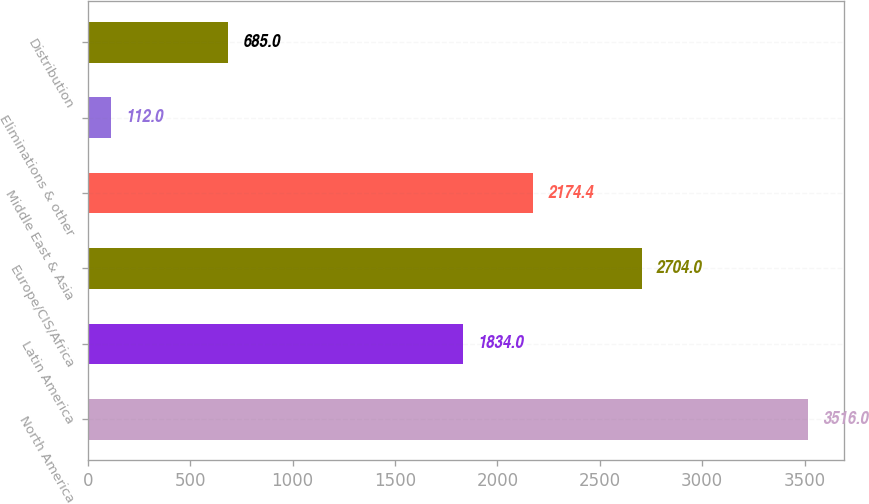Convert chart. <chart><loc_0><loc_0><loc_500><loc_500><bar_chart><fcel>North America<fcel>Latin America<fcel>Europe/CIS/Africa<fcel>Middle East & Asia<fcel>Eliminations & other<fcel>Distribution<nl><fcel>3516<fcel>1834<fcel>2704<fcel>2174.4<fcel>112<fcel>685<nl></chart> 